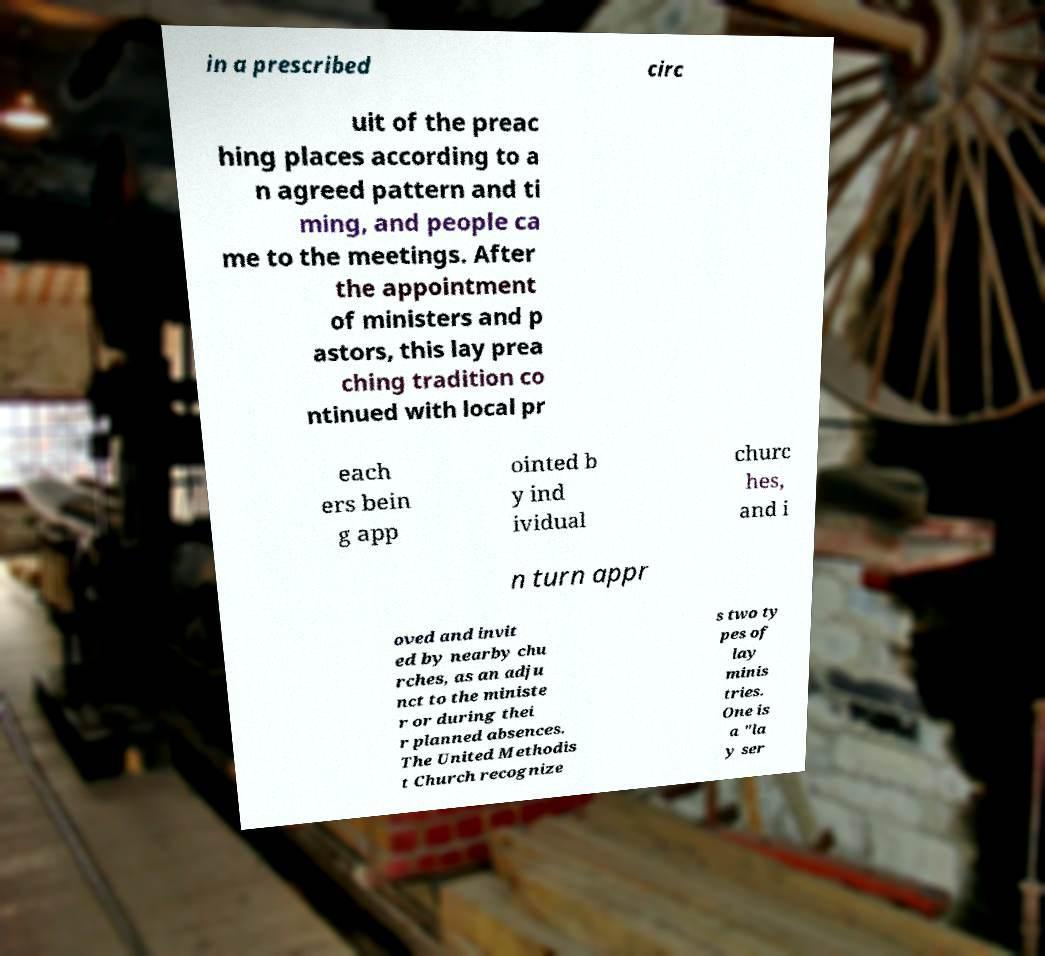What messages or text are displayed in this image? I need them in a readable, typed format. in a prescribed circ uit of the preac hing places according to a n agreed pattern and ti ming, and people ca me to the meetings. After the appointment of ministers and p astors, this lay prea ching tradition co ntinued with local pr each ers bein g app ointed b y ind ividual churc hes, and i n turn appr oved and invit ed by nearby chu rches, as an adju nct to the ministe r or during thei r planned absences. The United Methodis t Church recognize s two ty pes of lay minis tries. One is a "la y ser 